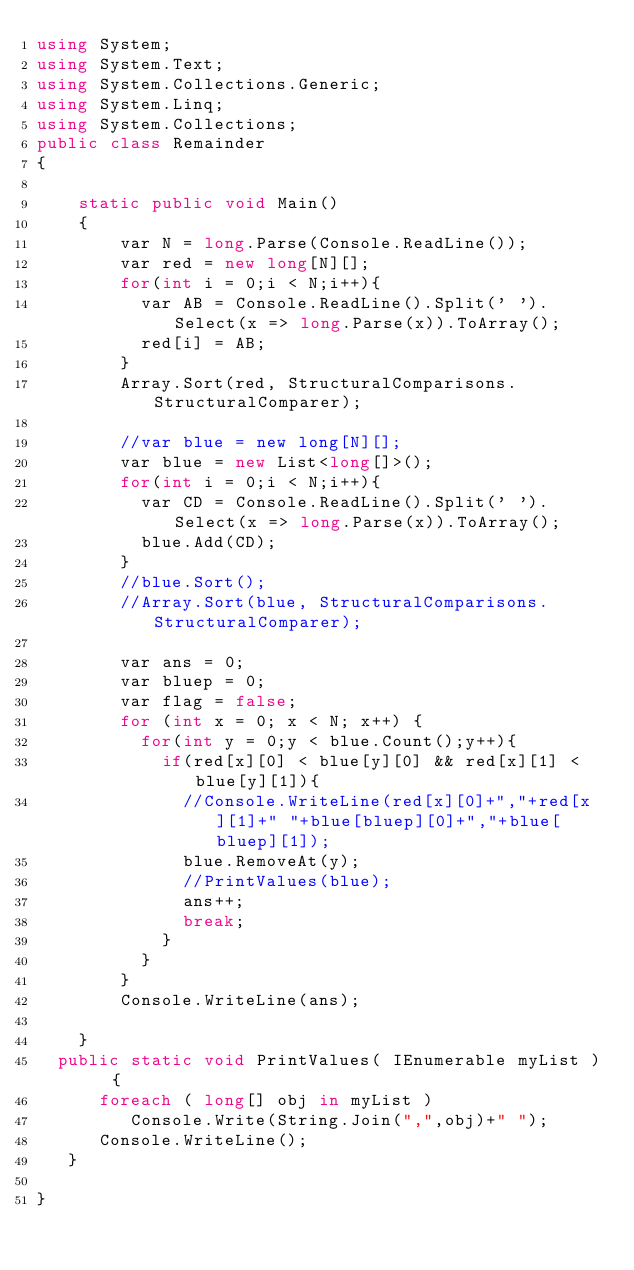<code> <loc_0><loc_0><loc_500><loc_500><_C#_>using System;
using System.Text;
using System.Collections.Generic;
using System.Linq;
using System.Collections;
public class Remainder
{

    static public void Main()
    {
        var N = long.Parse(Console.ReadLine());
        var red = new long[N][];
        for(int i = 0;i < N;i++){
          var AB = Console.ReadLine().Split(' ').Select(x => long.Parse(x)).ToArray();
          red[i] = AB;
        }
        Array.Sort(red, StructuralComparisons.StructuralComparer);
        
        //var blue = new long[N][];
        var blue = new List<long[]>();
        for(int i = 0;i < N;i++){
          var CD = Console.ReadLine().Split(' ').Select(x => long.Parse(x)).ToArray();
          blue.Add(CD);
        }
        //blue.Sort();
        //Array.Sort(blue, StructuralComparisons.StructuralComparer);
      
        var ans = 0;
        var bluep = 0;
        var flag = false;
        for (int x = 0; x < N; x++) {
          for(int y = 0;y < blue.Count();y++){
            if(red[x][0] < blue[y][0] && red[x][1] < blue[y][1]){
              //Console.WriteLine(red[x][0]+","+red[x][1]+" "+blue[bluep][0]+","+blue[bluep][1]);
              blue.RemoveAt(y);
              //PrintValues(blue);
              ans++;
              break;
            }
          }
        }
        Console.WriteLine(ans);

    }
  public static void PrintValues( IEnumerable myList )  {
      foreach ( long[] obj in myList )
         Console.Write(String.Join(",",obj)+" ");
      Console.WriteLine();
   }

}
</code> 